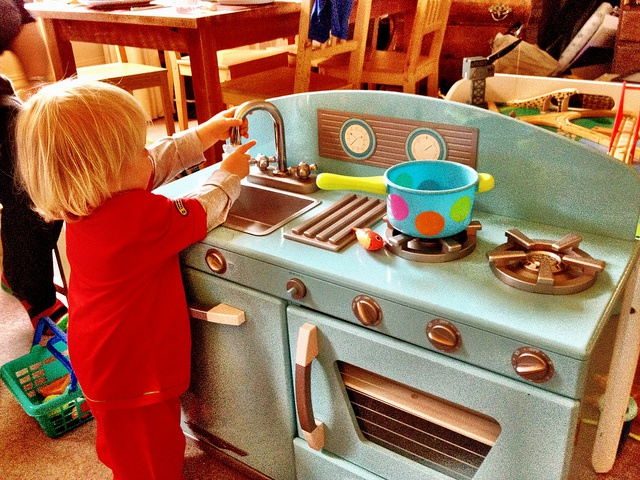Describe the objects in this image and their specific colors. I can see oven in brown, darkgray, gray, lightgray, and maroon tones, people in brown, red, and tan tones, dining table in brown, maroon, white, and red tones, people in brown, black, and maroon tones, and chair in brown, red, and orange tones in this image. 